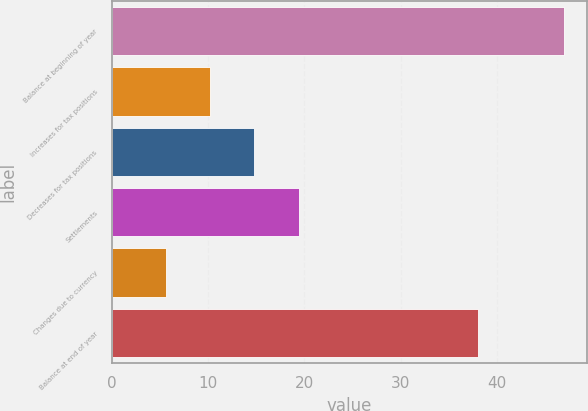Convert chart. <chart><loc_0><loc_0><loc_500><loc_500><bar_chart><fcel>Balance at beginning of year<fcel>Increases for tax positions<fcel>Decreases for tax positions<fcel>Settlements<fcel>Changes due to currency<fcel>Balance at end of year<nl><fcel>47<fcel>10.2<fcel>14.8<fcel>19.4<fcel>5.6<fcel>38<nl></chart> 